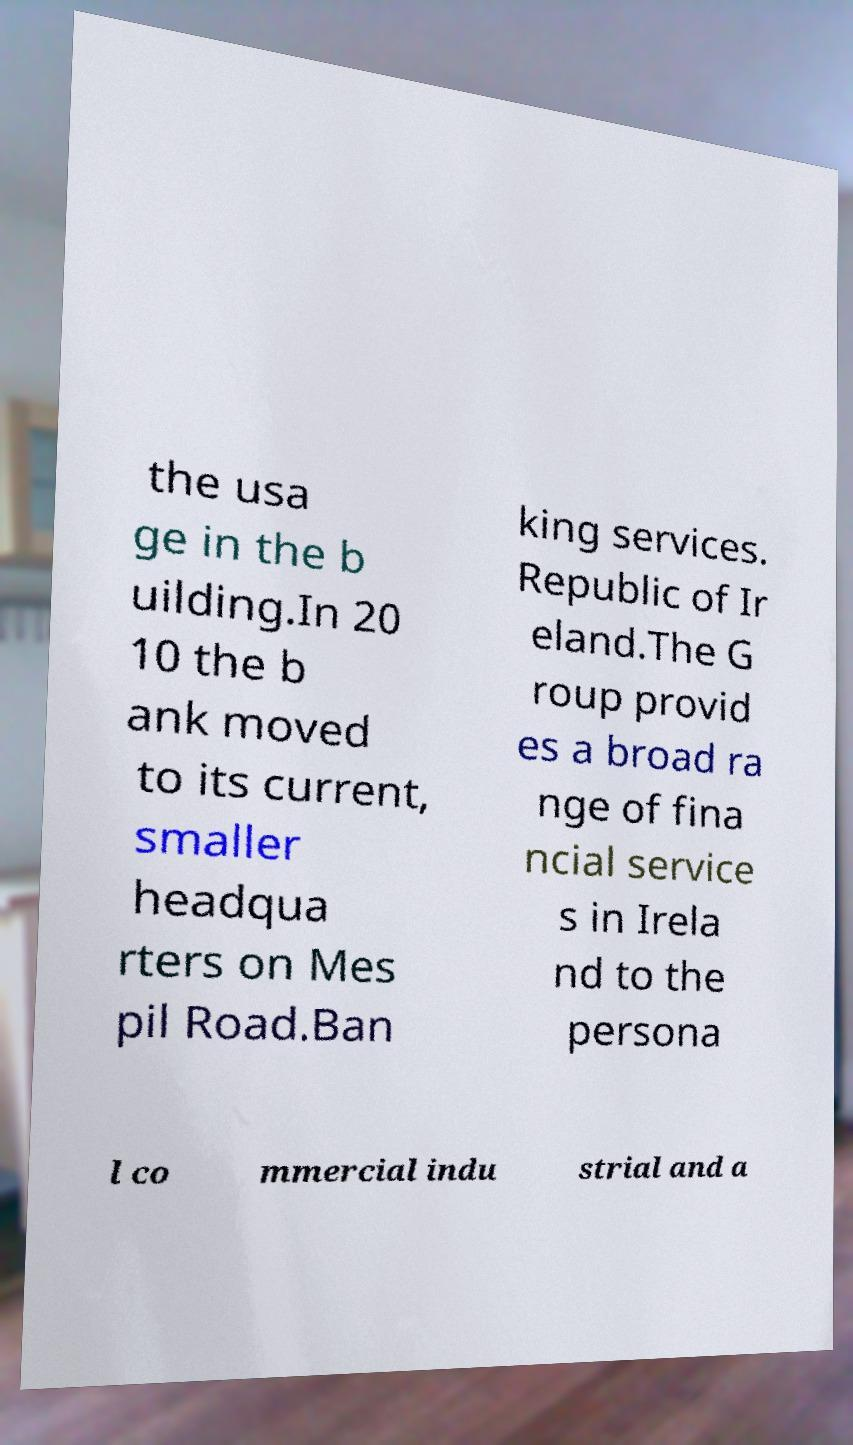Please read and relay the text visible in this image. What does it say? the usa ge in the b uilding.In 20 10 the b ank moved to its current, smaller headqua rters on Mes pil Road.Ban king services. Republic of Ir eland.The G roup provid es a broad ra nge of fina ncial service s in Irela nd to the persona l co mmercial indu strial and a 